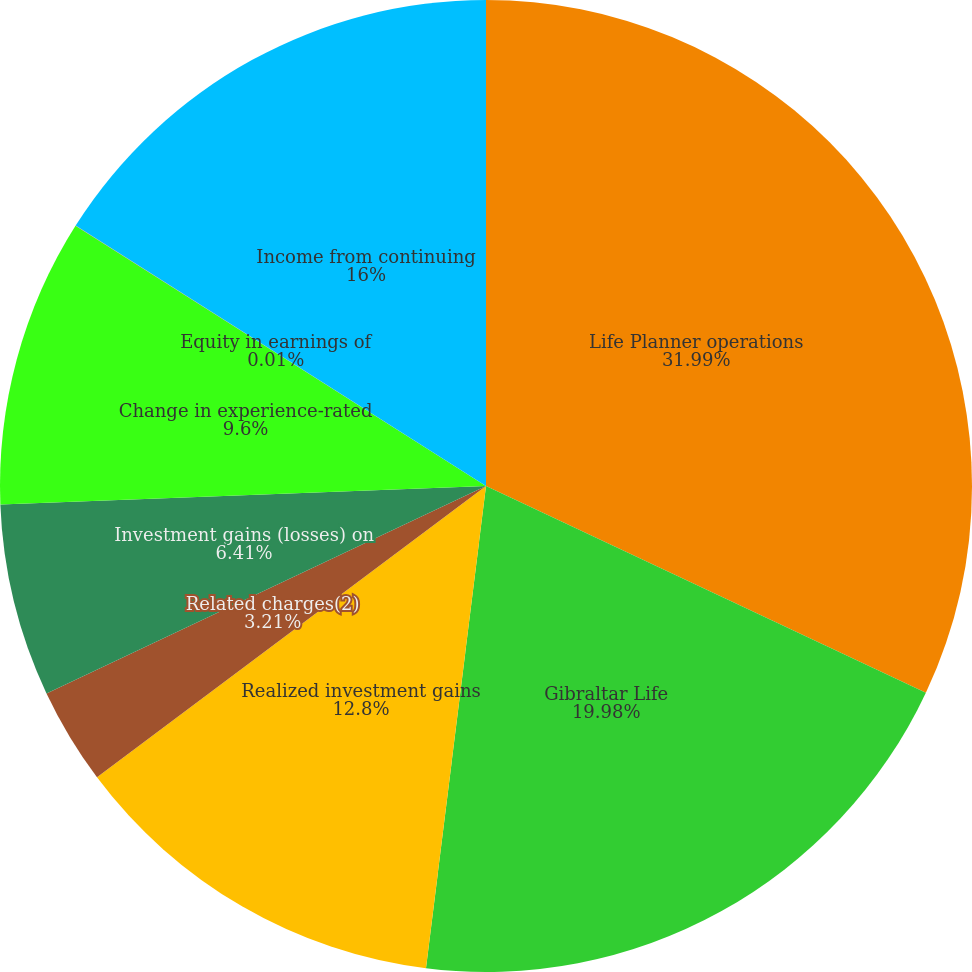Convert chart to OTSL. <chart><loc_0><loc_0><loc_500><loc_500><pie_chart><fcel>Life Planner operations<fcel>Gibraltar Life<fcel>Realized investment gains<fcel>Related charges(2)<fcel>Investment gains (losses) on<fcel>Change in experience-rated<fcel>Equity in earnings of<fcel>Income from continuing<nl><fcel>31.99%<fcel>19.98%<fcel>12.8%<fcel>3.21%<fcel>6.41%<fcel>9.6%<fcel>0.01%<fcel>16.0%<nl></chart> 